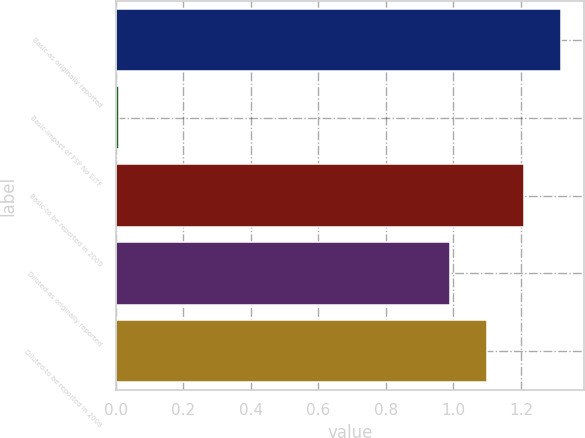Convert chart to OTSL. <chart><loc_0><loc_0><loc_500><loc_500><bar_chart><fcel>Basic-as originally reported<fcel>Basic-impact of FSP No EITF<fcel>Basic-to be reported in 2009<fcel>Diluted-as originally reported<fcel>Diluted-to be reported in 2009<nl><fcel>1.32<fcel>0.01<fcel>1.21<fcel>0.99<fcel>1.1<nl></chart> 